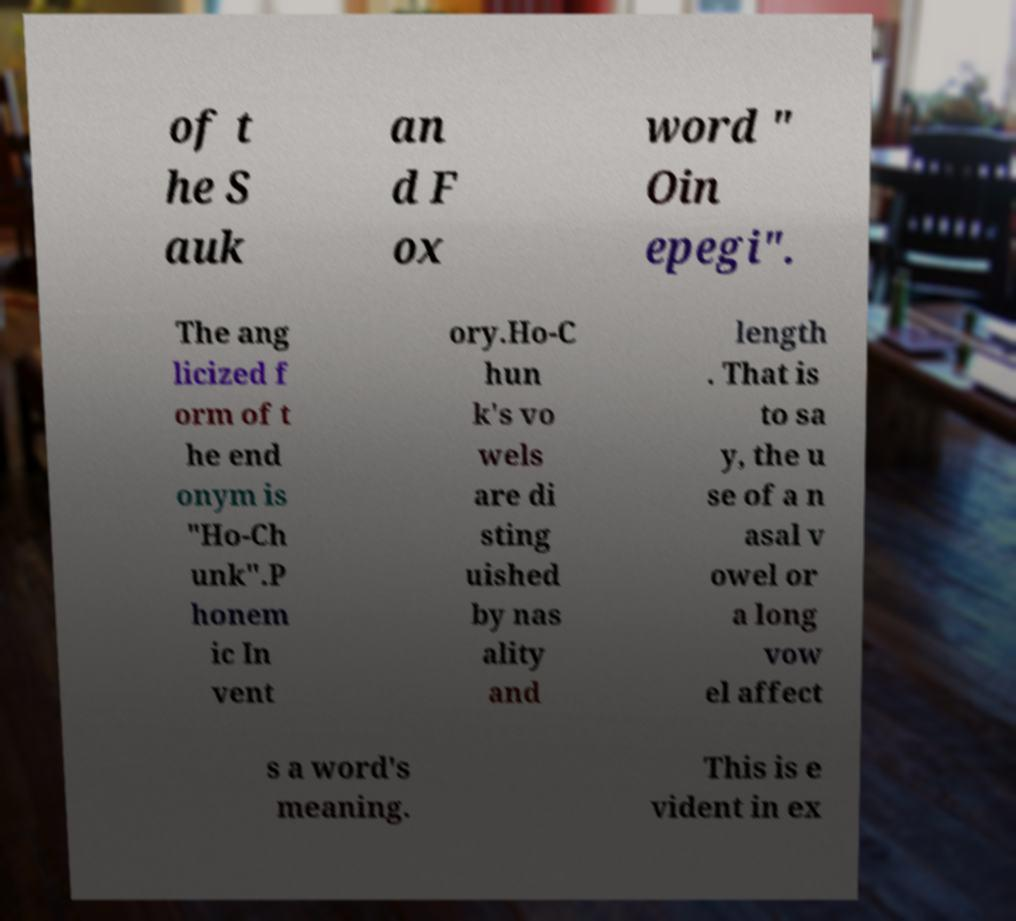Could you extract and type out the text from this image? of t he S auk an d F ox word " Oin epegi". The ang licized f orm of t he end onym is "Ho-Ch unk".P honem ic In vent ory.Ho-C hun k's vo wels are di sting uished by nas ality and length . That is to sa y, the u se of a n asal v owel or a long vow el affect s a word's meaning. This is e vident in ex 